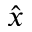Convert formula to latex. <formula><loc_0><loc_0><loc_500><loc_500>\hat { x }</formula> 